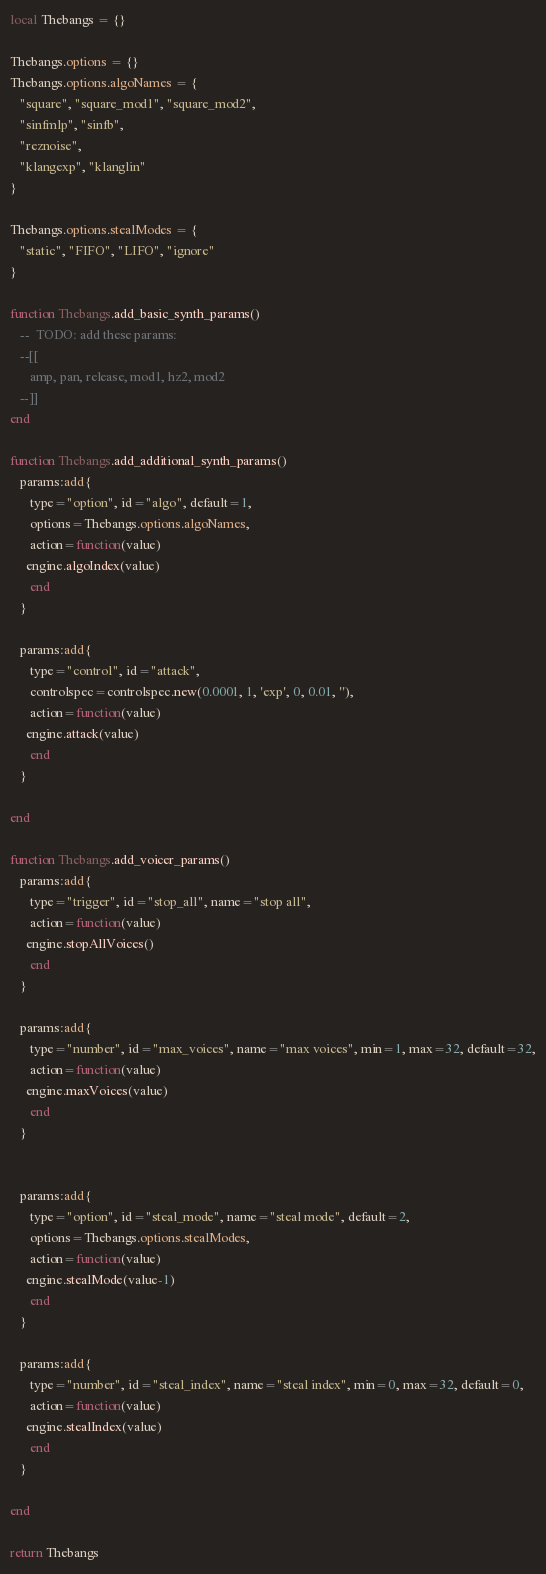<code> <loc_0><loc_0><loc_500><loc_500><_Lua_>local Thebangs = {}

Thebangs.options = {}
Thebangs.options.algoNames = {
   "square", "square_mod1", "square_mod2",
   "sinfmlp", "sinfb",
   "reznoise",
   "klangexp", "klanglin"
}

Thebangs.options.stealModes = {
   "static", "FIFO", "LIFO", "ignore"
}

function Thebangs.add_basic_synth_params()
   --  TODO: add these params:
   --[[
      amp, pan, release, mod1, hz2, mod2
   --]]
end

function Thebangs.add_additional_synth_params()   
   params:add{
      type="option", id="algo", default=1,
      options=Thebangs.options.algoNames,
      action=function(value)
	 engine.algoIndex(value)
      end
   }
   
   params:add{
      type="control", id="attack",
      controlspec=controlspec.new(0.0001, 1, 'exp', 0, 0.01, ''),
      action=function(value)
	 engine.attack(value)
      end
   }
   
end

function Thebangs.add_voicer_params()
   params:add{
      type="trigger", id="stop_all", name="stop all",
      action=function(value)
	 engine.stopAllVoices()
      end
   }
   
   params:add{
      type="number", id="max_voices", name="max voices", min=1, max=32, default=32,
      action=function(value)
	 engine.maxVoices(value)
      end
   }
   
   
   params:add{
      type="option", id="steal_mode", name="steal mode", default=2,
      options=Thebangs.options.stealModes,
      action=function(value)
	 engine.stealMode(value-1)
      end
   }
   
   params:add{
      type="number", id="steal_index", name="steal index", min=0, max=32, default=0,
      action=function(value)
	 engine.stealIndex(value)
      end
   }
   
end

return Thebangs
</code> 